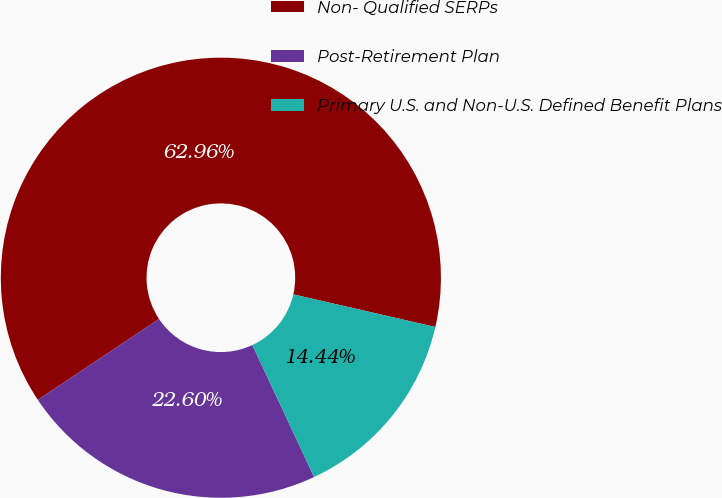Convert chart to OTSL. <chart><loc_0><loc_0><loc_500><loc_500><pie_chart><fcel>Non- Qualified SERPs<fcel>Post-Retirement Plan<fcel>Primary U.S. and Non-U.S. Defined Benefit Plans<nl><fcel>62.96%<fcel>22.6%<fcel>14.44%<nl></chart> 